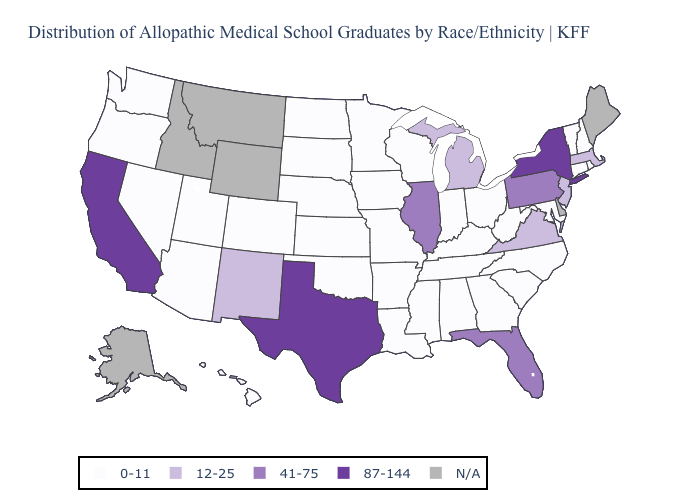What is the value of Alabama?
Keep it brief. 0-11. What is the value of Maryland?
Be succinct. 0-11. Which states have the lowest value in the South?
Keep it brief. Alabama, Arkansas, Georgia, Kentucky, Louisiana, Maryland, Mississippi, North Carolina, Oklahoma, South Carolina, Tennessee, West Virginia. Which states hav the highest value in the West?
Concise answer only. California. Does North Carolina have the lowest value in the USA?
Keep it brief. Yes. Among the states that border Oregon , does California have the lowest value?
Write a very short answer. No. Name the states that have a value in the range 12-25?
Quick response, please. Massachusetts, Michigan, New Jersey, New Mexico, Virginia. What is the value of Delaware?
Short answer required. N/A. What is the value of Iowa?
Write a very short answer. 0-11. Which states have the lowest value in the MidWest?
Keep it brief. Indiana, Iowa, Kansas, Minnesota, Missouri, Nebraska, North Dakota, Ohio, South Dakota, Wisconsin. Name the states that have a value in the range 41-75?
Short answer required. Florida, Illinois, Pennsylvania. How many symbols are there in the legend?
Keep it brief. 5. 